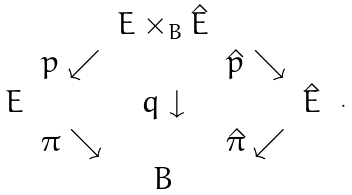Convert formula to latex. <formula><loc_0><loc_0><loc_500><loc_500>\begin{array} { c c c c c } & & E \times _ { B } \hat { E } & & \\ & p \swarrow & & \hat { p } \searrow & \\ E & & q \downarrow & & \hat { E } \\ & \pi \searrow & & \hat { \pi } \swarrow \\ & & B & & \end{array} \ .</formula> 